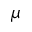<formula> <loc_0><loc_0><loc_500><loc_500>\mu</formula> 